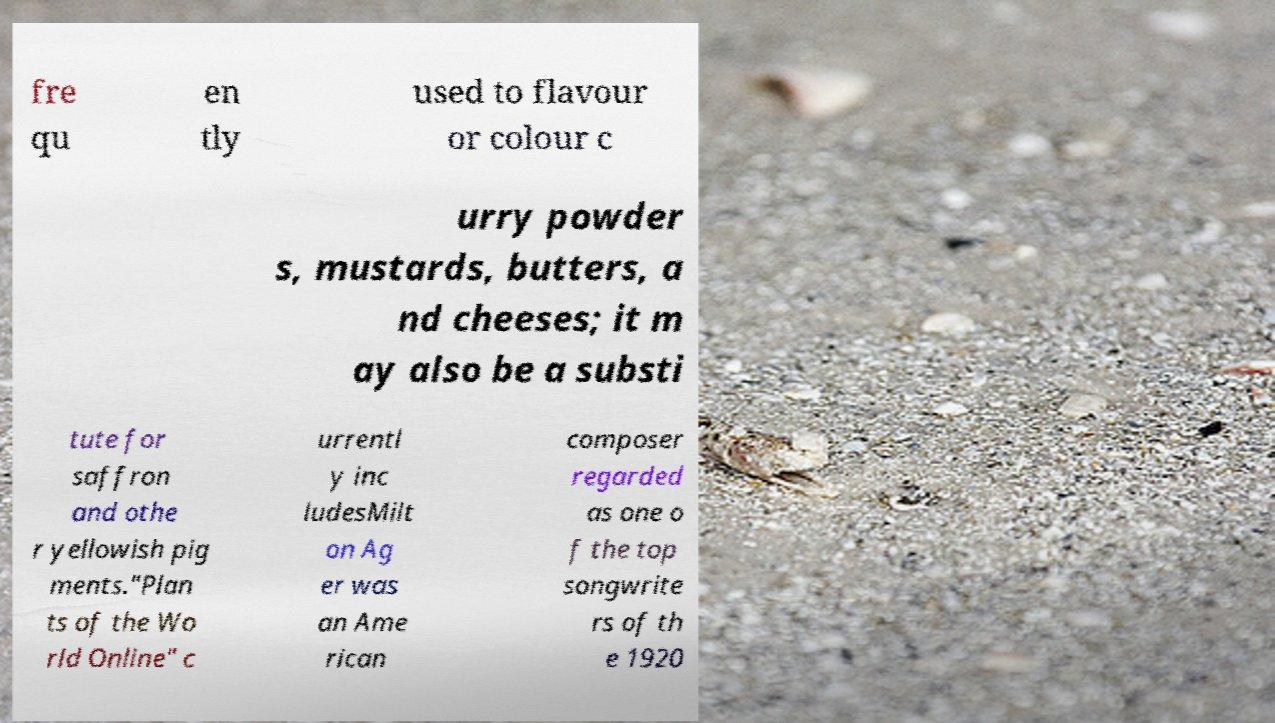For documentation purposes, I need the text within this image transcribed. Could you provide that? fre qu en tly used to flavour or colour c urry powder s, mustards, butters, a nd cheeses; it m ay also be a substi tute for saffron and othe r yellowish pig ments."Plan ts of the Wo rld Online" c urrentl y inc ludesMilt on Ag er was an Ame rican composer regarded as one o f the top songwrite rs of th e 1920 